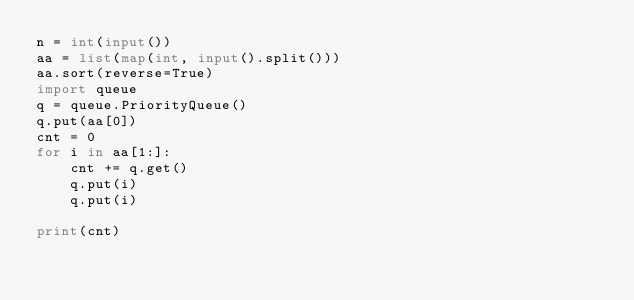<code> <loc_0><loc_0><loc_500><loc_500><_Python_>n = int(input())
aa = list(map(int, input().split()))
aa.sort(reverse=True)
import queue
q = queue.PriorityQueue()
q.put(aa[0])
cnt = 0
for i in aa[1:]:
    cnt += q.get()
    q.put(i)
    q.put(i)

print(cnt)</code> 